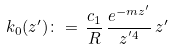Convert formula to latex. <formula><loc_0><loc_0><loc_500><loc_500>k _ { 0 } ( z ^ { \prime } ) \colon = \, \frac { c _ { 1 } } { R } \, \frac { e ^ { - m z ^ { \prime } } } { z ^ { ^ { \prime } 4 } } \, z ^ { \prime }</formula> 